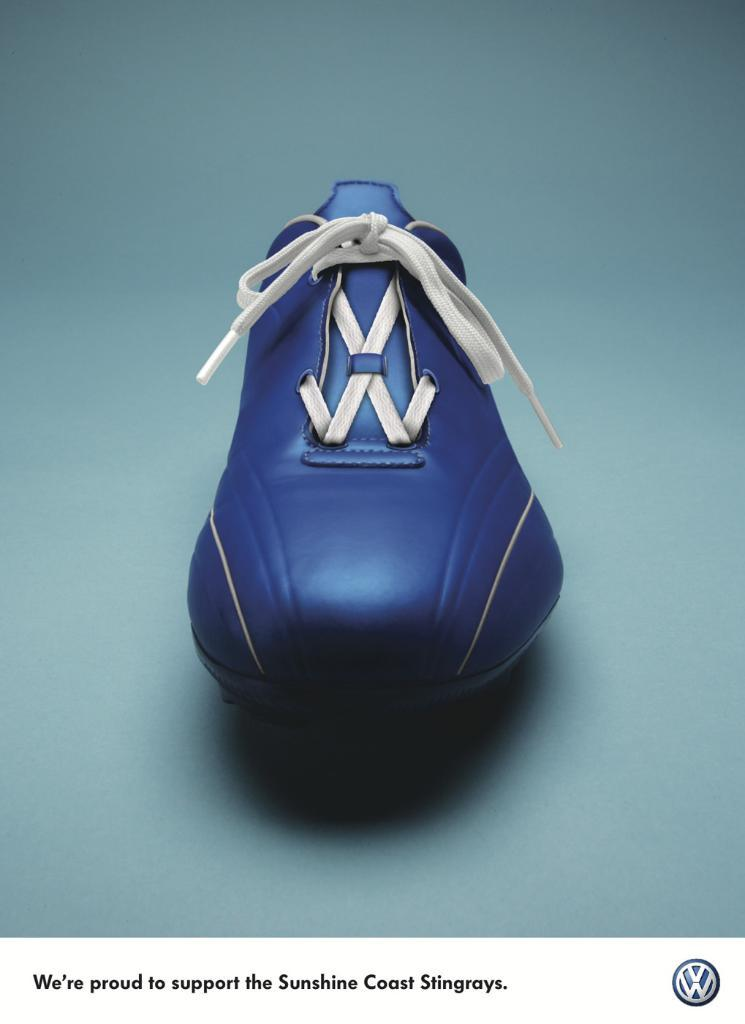Provide a one-sentence caption for the provided image. Blue shoe with the saying "We're proud to support the Sunshine Coast Stingrays". 